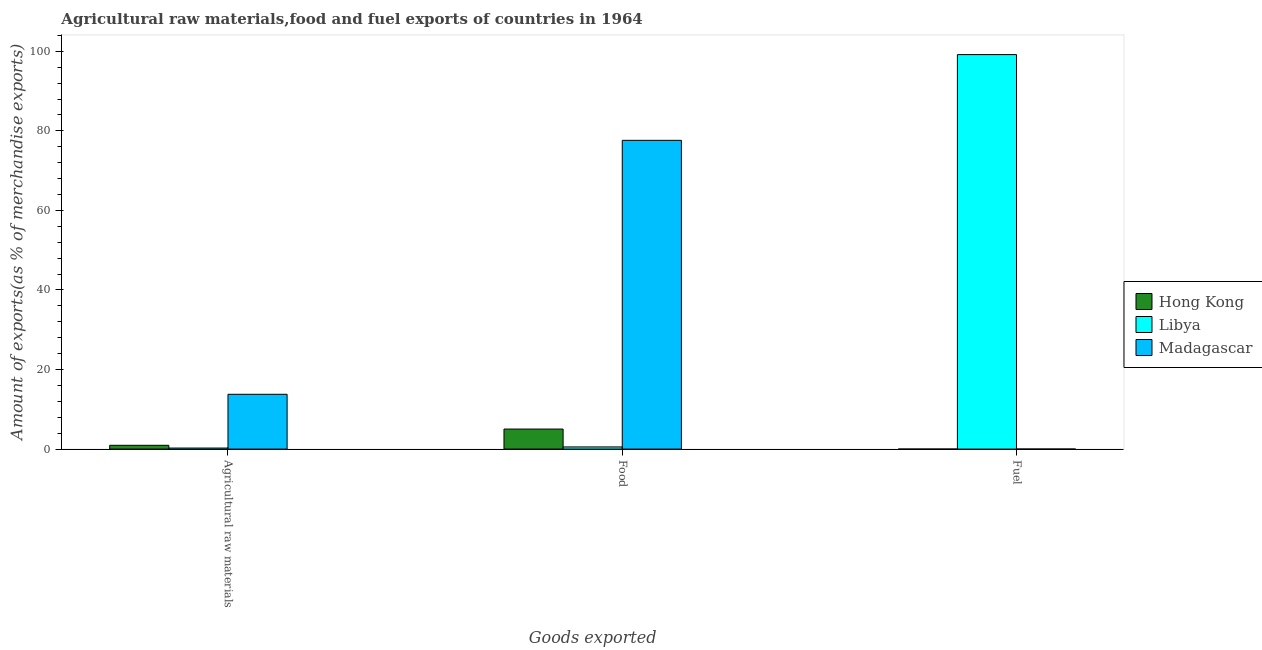How many different coloured bars are there?
Keep it short and to the point. 3. How many groups of bars are there?
Make the answer very short. 3. Are the number of bars per tick equal to the number of legend labels?
Your response must be concise. Yes. Are the number of bars on each tick of the X-axis equal?
Give a very brief answer. Yes. How many bars are there on the 2nd tick from the left?
Provide a short and direct response. 3. How many bars are there on the 2nd tick from the right?
Your answer should be compact. 3. What is the label of the 2nd group of bars from the left?
Offer a very short reply. Food. What is the percentage of fuel exports in Hong Kong?
Your response must be concise. 0. Across all countries, what is the maximum percentage of fuel exports?
Your response must be concise. 99.17. Across all countries, what is the minimum percentage of raw materials exports?
Offer a terse response. 0.26. In which country was the percentage of food exports maximum?
Offer a terse response. Madagascar. In which country was the percentage of fuel exports minimum?
Your answer should be compact. Hong Kong. What is the total percentage of fuel exports in the graph?
Ensure brevity in your answer.  99.17. What is the difference between the percentage of raw materials exports in Hong Kong and that in Libya?
Ensure brevity in your answer.  0.69. What is the difference between the percentage of food exports in Libya and the percentage of fuel exports in Hong Kong?
Offer a very short reply. 0.54. What is the average percentage of raw materials exports per country?
Make the answer very short. 4.99. What is the difference between the percentage of fuel exports and percentage of food exports in Libya?
Your response must be concise. 98.63. In how many countries, is the percentage of fuel exports greater than 48 %?
Your response must be concise. 1. What is the ratio of the percentage of food exports in Libya to that in Hong Kong?
Provide a short and direct response. 0.11. Is the percentage of food exports in Hong Kong less than that in Libya?
Your answer should be compact. No. What is the difference between the highest and the second highest percentage of food exports?
Your response must be concise. 72.58. What is the difference between the highest and the lowest percentage of raw materials exports?
Ensure brevity in your answer.  13.52. What does the 3rd bar from the left in Food represents?
Keep it short and to the point. Madagascar. What does the 3rd bar from the right in Agricultural raw materials represents?
Your response must be concise. Hong Kong. Is it the case that in every country, the sum of the percentage of raw materials exports and percentage of food exports is greater than the percentage of fuel exports?
Offer a very short reply. No. How many bars are there?
Ensure brevity in your answer.  9. Are all the bars in the graph horizontal?
Give a very brief answer. No. Are the values on the major ticks of Y-axis written in scientific E-notation?
Give a very brief answer. No. Does the graph contain grids?
Ensure brevity in your answer.  No. What is the title of the graph?
Offer a terse response. Agricultural raw materials,food and fuel exports of countries in 1964. Does "Comoros" appear as one of the legend labels in the graph?
Your answer should be very brief. No. What is the label or title of the X-axis?
Offer a terse response. Goods exported. What is the label or title of the Y-axis?
Offer a terse response. Amount of exports(as % of merchandise exports). What is the Amount of exports(as % of merchandise exports) in Hong Kong in Agricultural raw materials?
Your answer should be very brief. 0.95. What is the Amount of exports(as % of merchandise exports) of Libya in Agricultural raw materials?
Offer a terse response. 0.26. What is the Amount of exports(as % of merchandise exports) in Madagascar in Agricultural raw materials?
Your answer should be compact. 13.77. What is the Amount of exports(as % of merchandise exports) of Hong Kong in Food?
Make the answer very short. 5.03. What is the Amount of exports(as % of merchandise exports) in Libya in Food?
Offer a very short reply. 0.54. What is the Amount of exports(as % of merchandise exports) in Madagascar in Food?
Give a very brief answer. 77.61. What is the Amount of exports(as % of merchandise exports) of Hong Kong in Fuel?
Provide a succinct answer. 0. What is the Amount of exports(as % of merchandise exports) of Libya in Fuel?
Give a very brief answer. 99.17. What is the Amount of exports(as % of merchandise exports) of Madagascar in Fuel?
Ensure brevity in your answer.  0. Across all Goods exported, what is the maximum Amount of exports(as % of merchandise exports) in Hong Kong?
Ensure brevity in your answer.  5.03. Across all Goods exported, what is the maximum Amount of exports(as % of merchandise exports) in Libya?
Offer a very short reply. 99.17. Across all Goods exported, what is the maximum Amount of exports(as % of merchandise exports) in Madagascar?
Make the answer very short. 77.61. Across all Goods exported, what is the minimum Amount of exports(as % of merchandise exports) in Hong Kong?
Your answer should be very brief. 0. Across all Goods exported, what is the minimum Amount of exports(as % of merchandise exports) of Libya?
Offer a very short reply. 0.26. Across all Goods exported, what is the minimum Amount of exports(as % of merchandise exports) in Madagascar?
Offer a very short reply. 0. What is the total Amount of exports(as % of merchandise exports) in Hong Kong in the graph?
Make the answer very short. 5.98. What is the total Amount of exports(as % of merchandise exports) in Libya in the graph?
Give a very brief answer. 99.96. What is the total Amount of exports(as % of merchandise exports) of Madagascar in the graph?
Your response must be concise. 91.39. What is the difference between the Amount of exports(as % of merchandise exports) in Hong Kong in Agricultural raw materials and that in Food?
Offer a terse response. -4.08. What is the difference between the Amount of exports(as % of merchandise exports) of Libya in Agricultural raw materials and that in Food?
Provide a short and direct response. -0.28. What is the difference between the Amount of exports(as % of merchandise exports) of Madagascar in Agricultural raw materials and that in Food?
Your answer should be very brief. -63.84. What is the difference between the Amount of exports(as % of merchandise exports) in Hong Kong in Agricultural raw materials and that in Fuel?
Provide a short and direct response. 0.95. What is the difference between the Amount of exports(as % of merchandise exports) in Libya in Agricultural raw materials and that in Fuel?
Your answer should be compact. -98.91. What is the difference between the Amount of exports(as % of merchandise exports) of Madagascar in Agricultural raw materials and that in Fuel?
Offer a terse response. 13.77. What is the difference between the Amount of exports(as % of merchandise exports) of Hong Kong in Food and that in Fuel?
Keep it short and to the point. 5.03. What is the difference between the Amount of exports(as % of merchandise exports) in Libya in Food and that in Fuel?
Provide a succinct answer. -98.63. What is the difference between the Amount of exports(as % of merchandise exports) of Madagascar in Food and that in Fuel?
Give a very brief answer. 77.61. What is the difference between the Amount of exports(as % of merchandise exports) in Hong Kong in Agricultural raw materials and the Amount of exports(as % of merchandise exports) in Libya in Food?
Keep it short and to the point. 0.41. What is the difference between the Amount of exports(as % of merchandise exports) of Hong Kong in Agricultural raw materials and the Amount of exports(as % of merchandise exports) of Madagascar in Food?
Give a very brief answer. -76.66. What is the difference between the Amount of exports(as % of merchandise exports) in Libya in Agricultural raw materials and the Amount of exports(as % of merchandise exports) in Madagascar in Food?
Give a very brief answer. -77.35. What is the difference between the Amount of exports(as % of merchandise exports) of Hong Kong in Agricultural raw materials and the Amount of exports(as % of merchandise exports) of Libya in Fuel?
Ensure brevity in your answer.  -98.22. What is the difference between the Amount of exports(as % of merchandise exports) in Libya in Agricultural raw materials and the Amount of exports(as % of merchandise exports) in Madagascar in Fuel?
Keep it short and to the point. 0.25. What is the difference between the Amount of exports(as % of merchandise exports) of Hong Kong in Food and the Amount of exports(as % of merchandise exports) of Libya in Fuel?
Give a very brief answer. -94.13. What is the difference between the Amount of exports(as % of merchandise exports) in Hong Kong in Food and the Amount of exports(as % of merchandise exports) in Madagascar in Fuel?
Offer a terse response. 5.03. What is the difference between the Amount of exports(as % of merchandise exports) of Libya in Food and the Amount of exports(as % of merchandise exports) of Madagascar in Fuel?
Give a very brief answer. 0.54. What is the average Amount of exports(as % of merchandise exports) in Hong Kong per Goods exported?
Ensure brevity in your answer.  1.99. What is the average Amount of exports(as % of merchandise exports) in Libya per Goods exported?
Offer a terse response. 33.32. What is the average Amount of exports(as % of merchandise exports) of Madagascar per Goods exported?
Make the answer very short. 30.46. What is the difference between the Amount of exports(as % of merchandise exports) of Hong Kong and Amount of exports(as % of merchandise exports) of Libya in Agricultural raw materials?
Make the answer very short. 0.69. What is the difference between the Amount of exports(as % of merchandise exports) in Hong Kong and Amount of exports(as % of merchandise exports) in Madagascar in Agricultural raw materials?
Your answer should be very brief. -12.83. What is the difference between the Amount of exports(as % of merchandise exports) in Libya and Amount of exports(as % of merchandise exports) in Madagascar in Agricultural raw materials?
Provide a succinct answer. -13.52. What is the difference between the Amount of exports(as % of merchandise exports) in Hong Kong and Amount of exports(as % of merchandise exports) in Libya in Food?
Provide a succinct answer. 4.49. What is the difference between the Amount of exports(as % of merchandise exports) of Hong Kong and Amount of exports(as % of merchandise exports) of Madagascar in Food?
Keep it short and to the point. -72.58. What is the difference between the Amount of exports(as % of merchandise exports) in Libya and Amount of exports(as % of merchandise exports) in Madagascar in Food?
Your answer should be very brief. -77.07. What is the difference between the Amount of exports(as % of merchandise exports) in Hong Kong and Amount of exports(as % of merchandise exports) in Libya in Fuel?
Ensure brevity in your answer.  -99.17. What is the difference between the Amount of exports(as % of merchandise exports) in Hong Kong and Amount of exports(as % of merchandise exports) in Madagascar in Fuel?
Provide a succinct answer. -0. What is the difference between the Amount of exports(as % of merchandise exports) in Libya and Amount of exports(as % of merchandise exports) in Madagascar in Fuel?
Your response must be concise. 99.16. What is the ratio of the Amount of exports(as % of merchandise exports) of Hong Kong in Agricultural raw materials to that in Food?
Give a very brief answer. 0.19. What is the ratio of the Amount of exports(as % of merchandise exports) in Libya in Agricultural raw materials to that in Food?
Offer a terse response. 0.48. What is the ratio of the Amount of exports(as % of merchandise exports) of Madagascar in Agricultural raw materials to that in Food?
Give a very brief answer. 0.18. What is the ratio of the Amount of exports(as % of merchandise exports) in Hong Kong in Agricultural raw materials to that in Fuel?
Your response must be concise. 6091.1. What is the ratio of the Amount of exports(as % of merchandise exports) of Libya in Agricultural raw materials to that in Fuel?
Your answer should be very brief. 0. What is the ratio of the Amount of exports(as % of merchandise exports) of Madagascar in Agricultural raw materials to that in Fuel?
Provide a short and direct response. 3103.1. What is the ratio of the Amount of exports(as % of merchandise exports) in Hong Kong in Food to that in Fuel?
Provide a succinct answer. 3.23e+04. What is the ratio of the Amount of exports(as % of merchandise exports) in Libya in Food to that in Fuel?
Offer a very short reply. 0.01. What is the ratio of the Amount of exports(as % of merchandise exports) of Madagascar in Food to that in Fuel?
Keep it short and to the point. 1.75e+04. What is the difference between the highest and the second highest Amount of exports(as % of merchandise exports) of Hong Kong?
Your response must be concise. 4.08. What is the difference between the highest and the second highest Amount of exports(as % of merchandise exports) of Libya?
Make the answer very short. 98.63. What is the difference between the highest and the second highest Amount of exports(as % of merchandise exports) in Madagascar?
Your answer should be very brief. 63.84. What is the difference between the highest and the lowest Amount of exports(as % of merchandise exports) of Hong Kong?
Make the answer very short. 5.03. What is the difference between the highest and the lowest Amount of exports(as % of merchandise exports) of Libya?
Ensure brevity in your answer.  98.91. What is the difference between the highest and the lowest Amount of exports(as % of merchandise exports) in Madagascar?
Offer a very short reply. 77.61. 